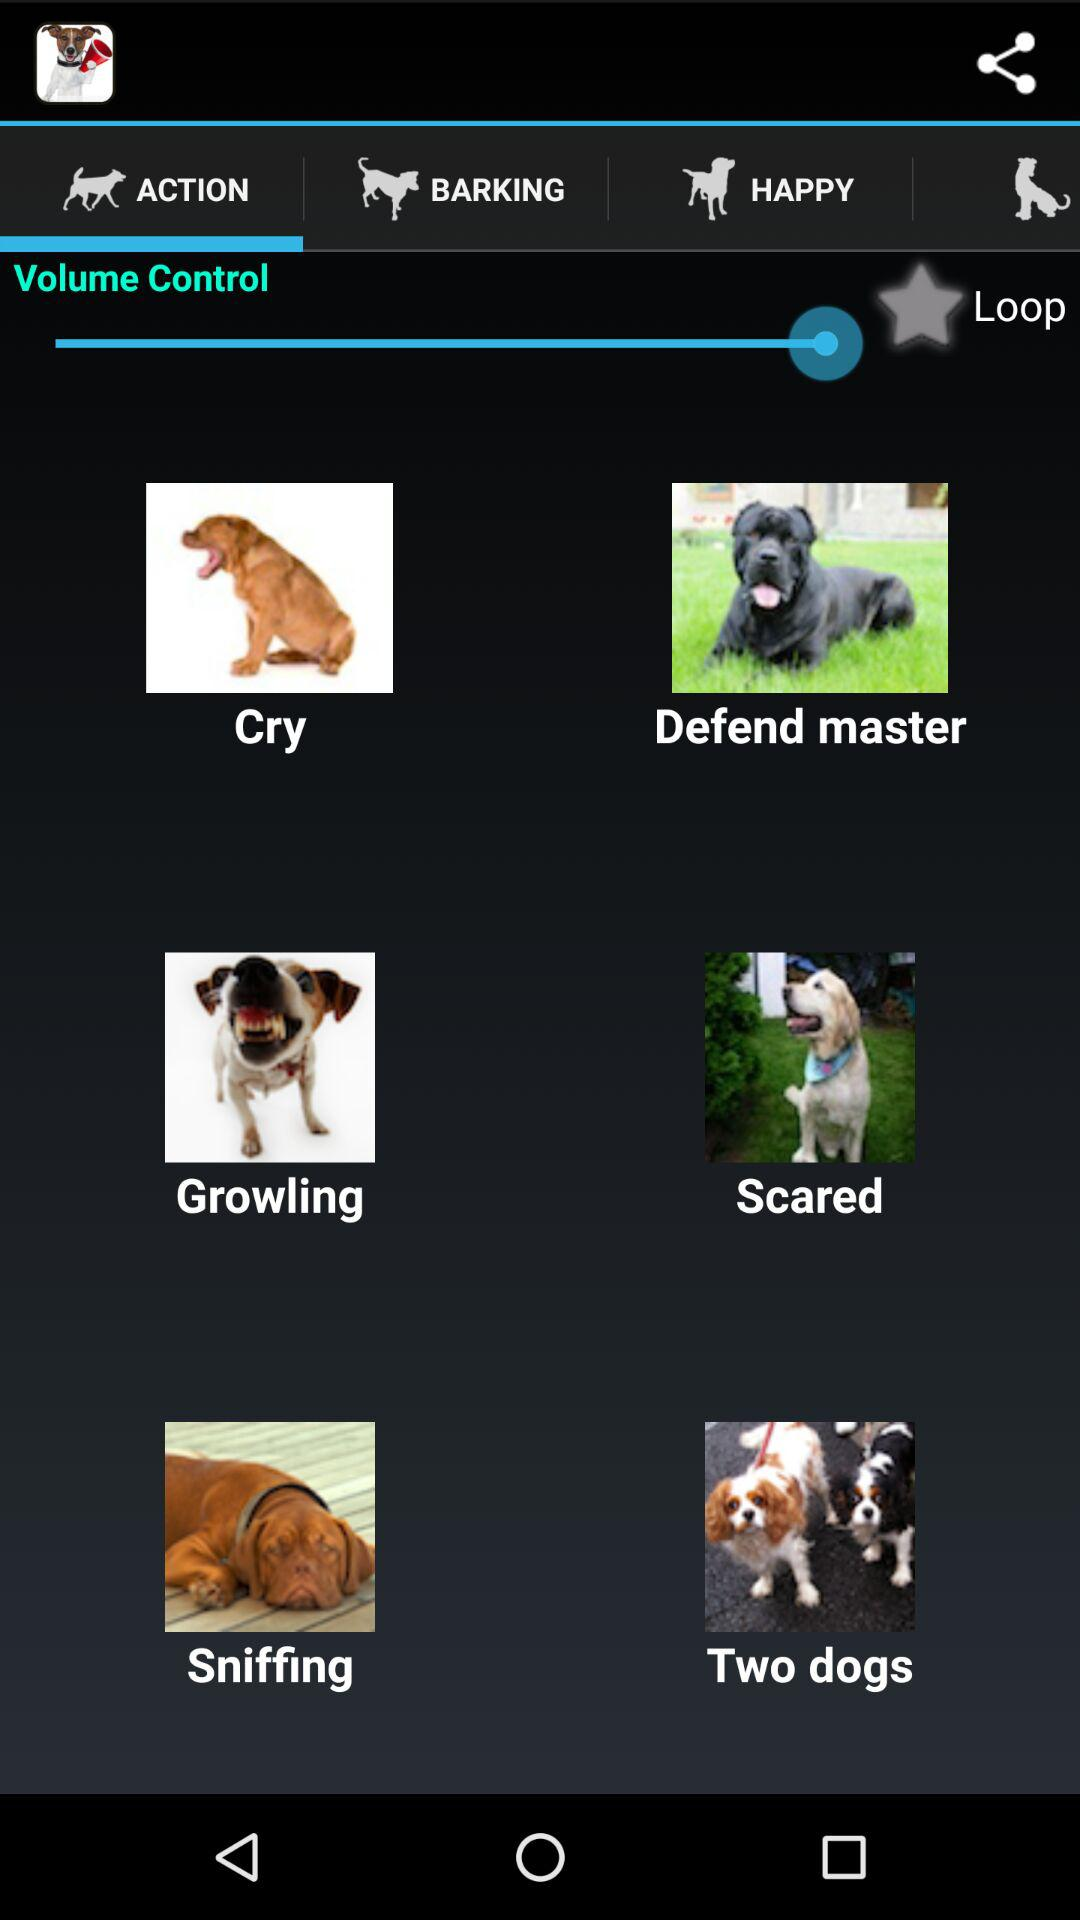Which tab is selected? The selected tab is "ACTION". 